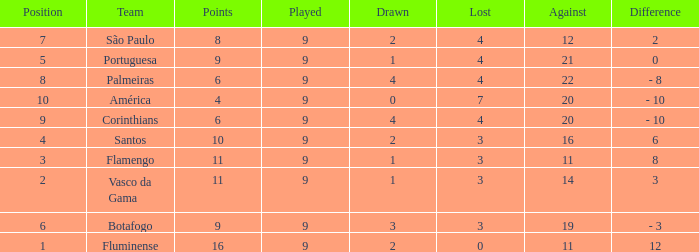Can you give me this table as a dict? {'header': ['Position', 'Team', 'Points', 'Played', 'Drawn', 'Lost', 'Against', 'Difference'], 'rows': [['7', 'São Paulo', '8', '9', '2', '4', '12', '2'], ['5', 'Portuguesa', '9', '9', '1', '4', '21', '0'], ['8', 'Palmeiras', '6', '9', '4', '4', '22', '- 8'], ['10', 'América', '4', '9', '0', '7', '20', '- 10'], ['9', 'Corinthians', '6', '9', '4', '4', '20', '- 10'], ['4', 'Santos', '10', '9', '2', '3', '16', '6'], ['3', 'Flamengo', '11', '9', '1', '3', '11', '8'], ['2', 'Vasco da Gama', '11', '9', '1', '3', '14', '3'], ['6', 'Botafogo', '9', '9', '3', '3', '19', '- 3'], ['1', 'Fluminense', '16', '9', '2', '0', '11', '12']]} In which average played, does the drawn value fall under 1 while points surpass 4? None. 